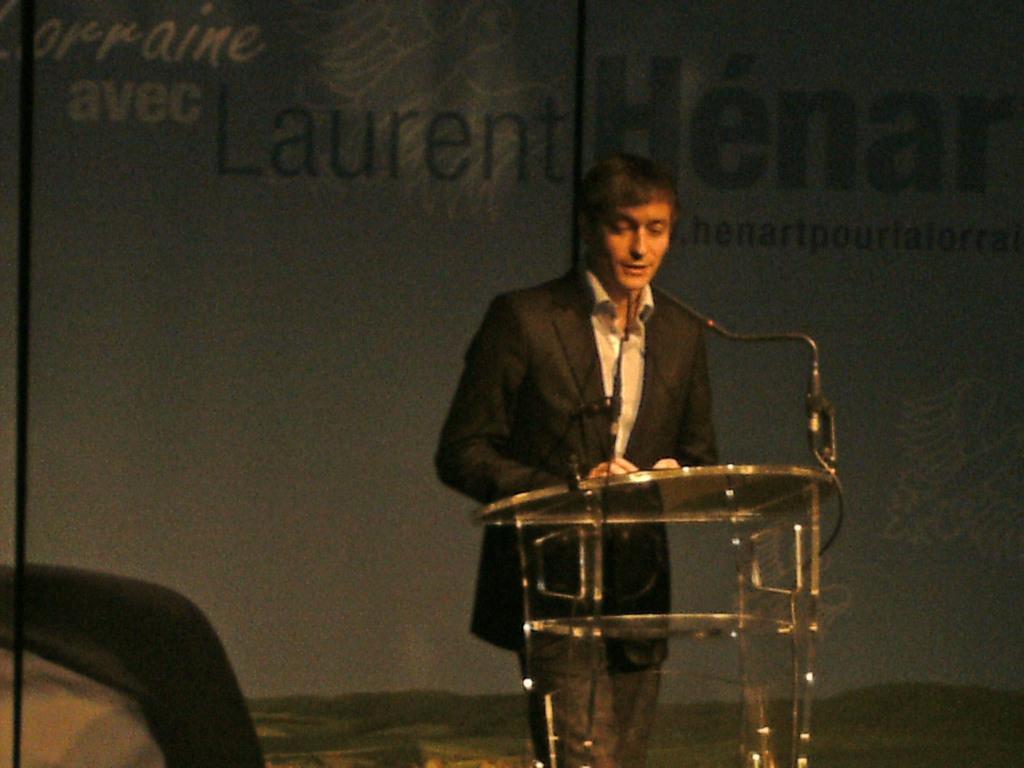Please provide a concise description of this image. In this image, we can see a person wearing clothes and standing in front of the podium. There is a text at the top of the image. 